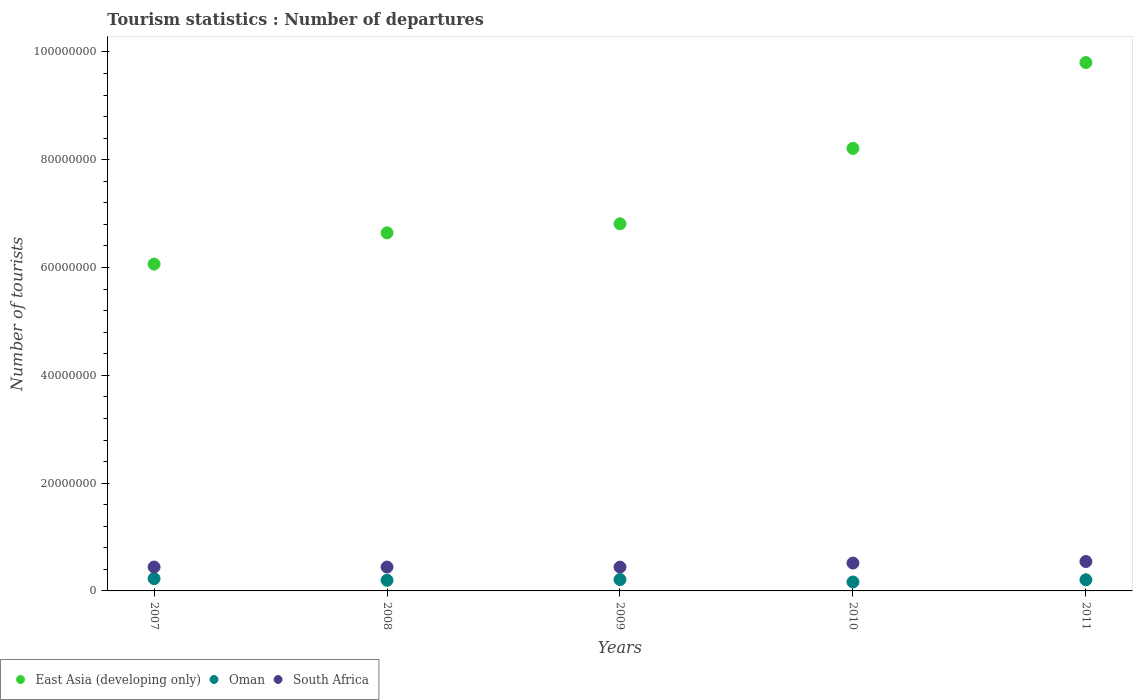What is the number of tourist departures in East Asia (developing only) in 2010?
Provide a short and direct response. 8.21e+07. Across all years, what is the maximum number of tourist departures in East Asia (developing only)?
Offer a very short reply. 9.80e+07. Across all years, what is the minimum number of tourist departures in South Africa?
Your answer should be very brief. 4.42e+06. What is the total number of tourist departures in Oman in the graph?
Offer a very short reply. 1.01e+07. What is the difference between the number of tourist departures in South Africa in 2007 and that in 2008?
Keep it short and to the point. 4000. What is the difference between the number of tourist departures in Oman in 2009 and the number of tourist departures in East Asia (developing only) in 2008?
Ensure brevity in your answer.  -6.43e+07. What is the average number of tourist departures in Oman per year?
Your answer should be very brief. 2.02e+06. In the year 2009, what is the difference between the number of tourist departures in Oman and number of tourist departures in East Asia (developing only)?
Provide a succinct answer. -6.60e+07. In how many years, is the number of tourist departures in South Africa greater than 56000000?
Your response must be concise. 0. What is the ratio of the number of tourist departures in South Africa in 2010 to that in 2011?
Your response must be concise. 0.95. Is the number of tourist departures in East Asia (developing only) in 2007 less than that in 2010?
Make the answer very short. Yes. Is the difference between the number of tourist departures in Oman in 2007 and 2008 greater than the difference between the number of tourist departures in East Asia (developing only) in 2007 and 2008?
Give a very brief answer. Yes. What is the difference between the highest and the lowest number of tourist departures in South Africa?
Offer a terse response. 1.03e+06. In how many years, is the number of tourist departures in South Africa greater than the average number of tourist departures in South Africa taken over all years?
Ensure brevity in your answer.  2. Does the number of tourist departures in Oman monotonically increase over the years?
Your answer should be compact. No. Is the number of tourist departures in East Asia (developing only) strictly greater than the number of tourist departures in South Africa over the years?
Give a very brief answer. Yes. Is the number of tourist departures in Oman strictly less than the number of tourist departures in South Africa over the years?
Give a very brief answer. Yes. How many dotlines are there?
Offer a terse response. 3. Does the graph contain any zero values?
Offer a very short reply. No. Does the graph contain grids?
Your response must be concise. No. What is the title of the graph?
Ensure brevity in your answer.  Tourism statistics : Number of departures. Does "Andorra" appear as one of the legend labels in the graph?
Ensure brevity in your answer.  No. What is the label or title of the X-axis?
Your response must be concise. Years. What is the label or title of the Y-axis?
Provide a succinct answer. Number of tourists. What is the Number of tourists of East Asia (developing only) in 2007?
Your answer should be compact. 6.06e+07. What is the Number of tourists in Oman in 2007?
Provide a succinct answer. 2.28e+06. What is the Number of tourists in South Africa in 2007?
Offer a terse response. 4.43e+06. What is the Number of tourists in East Asia (developing only) in 2008?
Provide a short and direct response. 6.64e+07. What is the Number of tourists in Oman in 2008?
Your answer should be compact. 1.97e+06. What is the Number of tourists of South Africa in 2008?
Your answer should be compact. 4.43e+06. What is the Number of tourists in East Asia (developing only) in 2009?
Ensure brevity in your answer.  6.81e+07. What is the Number of tourists in Oman in 2009?
Keep it short and to the point. 2.11e+06. What is the Number of tourists of South Africa in 2009?
Offer a terse response. 4.42e+06. What is the Number of tourists of East Asia (developing only) in 2010?
Provide a succinct answer. 8.21e+07. What is the Number of tourists in Oman in 2010?
Provide a short and direct response. 1.66e+06. What is the Number of tourists in South Africa in 2010?
Your response must be concise. 5.16e+06. What is the Number of tourists of East Asia (developing only) in 2011?
Make the answer very short. 9.80e+07. What is the Number of tourists of Oman in 2011?
Your answer should be very brief. 2.06e+06. What is the Number of tourists in South Africa in 2011?
Ensure brevity in your answer.  5.46e+06. Across all years, what is the maximum Number of tourists in East Asia (developing only)?
Your answer should be compact. 9.80e+07. Across all years, what is the maximum Number of tourists of Oman?
Provide a succinct answer. 2.28e+06. Across all years, what is the maximum Number of tourists in South Africa?
Offer a very short reply. 5.46e+06. Across all years, what is the minimum Number of tourists in East Asia (developing only)?
Keep it short and to the point. 6.06e+07. Across all years, what is the minimum Number of tourists in Oman?
Your answer should be very brief. 1.66e+06. Across all years, what is the minimum Number of tourists of South Africa?
Provide a short and direct response. 4.42e+06. What is the total Number of tourists of East Asia (developing only) in the graph?
Give a very brief answer. 3.75e+08. What is the total Number of tourists of Oman in the graph?
Offer a very short reply. 1.01e+07. What is the total Number of tourists of South Africa in the graph?
Keep it short and to the point. 2.39e+07. What is the difference between the Number of tourists in East Asia (developing only) in 2007 and that in 2008?
Ensure brevity in your answer.  -5.80e+06. What is the difference between the Number of tourists in Oman in 2007 and that in 2008?
Provide a short and direct response. 3.12e+05. What is the difference between the Number of tourists of South Africa in 2007 and that in 2008?
Make the answer very short. 4000. What is the difference between the Number of tourists in East Asia (developing only) in 2007 and that in 2009?
Make the answer very short. -7.47e+06. What is the difference between the Number of tourists of Oman in 2007 and that in 2009?
Your response must be concise. 1.77e+05. What is the difference between the Number of tourists in South Africa in 2007 and that in 2009?
Your answer should be compact. 9000. What is the difference between the Number of tourists in East Asia (developing only) in 2007 and that in 2010?
Your answer should be very brief. -2.15e+07. What is the difference between the Number of tourists of Oman in 2007 and that in 2010?
Provide a succinct answer. 6.30e+05. What is the difference between the Number of tourists of South Africa in 2007 and that in 2010?
Offer a very short reply. -7.32e+05. What is the difference between the Number of tourists of East Asia (developing only) in 2007 and that in 2011?
Your response must be concise. -3.74e+07. What is the difference between the Number of tourists in South Africa in 2007 and that in 2011?
Your answer should be very brief. -1.02e+06. What is the difference between the Number of tourists in East Asia (developing only) in 2008 and that in 2009?
Your answer should be very brief. -1.68e+06. What is the difference between the Number of tourists in Oman in 2008 and that in 2009?
Your answer should be compact. -1.35e+05. What is the difference between the Number of tourists of East Asia (developing only) in 2008 and that in 2010?
Ensure brevity in your answer.  -1.57e+07. What is the difference between the Number of tourists in Oman in 2008 and that in 2010?
Provide a short and direct response. 3.18e+05. What is the difference between the Number of tourists of South Africa in 2008 and that in 2010?
Offer a very short reply. -7.36e+05. What is the difference between the Number of tourists in East Asia (developing only) in 2008 and that in 2011?
Make the answer very short. -3.16e+07. What is the difference between the Number of tourists of Oman in 2008 and that in 2011?
Give a very brief answer. -9.20e+04. What is the difference between the Number of tourists in South Africa in 2008 and that in 2011?
Your answer should be very brief. -1.03e+06. What is the difference between the Number of tourists of East Asia (developing only) in 2009 and that in 2010?
Your answer should be very brief. -1.40e+07. What is the difference between the Number of tourists in Oman in 2009 and that in 2010?
Keep it short and to the point. 4.53e+05. What is the difference between the Number of tourists in South Africa in 2009 and that in 2010?
Keep it short and to the point. -7.41e+05. What is the difference between the Number of tourists in East Asia (developing only) in 2009 and that in 2011?
Your response must be concise. -2.99e+07. What is the difference between the Number of tourists in Oman in 2009 and that in 2011?
Give a very brief answer. 4.30e+04. What is the difference between the Number of tourists in South Africa in 2009 and that in 2011?
Offer a very short reply. -1.03e+06. What is the difference between the Number of tourists of East Asia (developing only) in 2010 and that in 2011?
Your response must be concise. -1.59e+07. What is the difference between the Number of tourists in Oman in 2010 and that in 2011?
Provide a short and direct response. -4.10e+05. What is the difference between the Number of tourists in South Africa in 2010 and that in 2011?
Make the answer very short. -2.90e+05. What is the difference between the Number of tourists of East Asia (developing only) in 2007 and the Number of tourists of Oman in 2008?
Keep it short and to the point. 5.87e+07. What is the difference between the Number of tourists in East Asia (developing only) in 2007 and the Number of tourists in South Africa in 2008?
Provide a succinct answer. 5.62e+07. What is the difference between the Number of tourists of Oman in 2007 and the Number of tourists of South Africa in 2008?
Your answer should be compact. -2.14e+06. What is the difference between the Number of tourists in East Asia (developing only) in 2007 and the Number of tourists in Oman in 2009?
Keep it short and to the point. 5.85e+07. What is the difference between the Number of tourists in East Asia (developing only) in 2007 and the Number of tourists in South Africa in 2009?
Provide a succinct answer. 5.62e+07. What is the difference between the Number of tourists in Oman in 2007 and the Number of tourists in South Africa in 2009?
Offer a terse response. -2.14e+06. What is the difference between the Number of tourists in East Asia (developing only) in 2007 and the Number of tourists in Oman in 2010?
Offer a very short reply. 5.90e+07. What is the difference between the Number of tourists in East Asia (developing only) in 2007 and the Number of tourists in South Africa in 2010?
Provide a short and direct response. 5.55e+07. What is the difference between the Number of tourists of Oman in 2007 and the Number of tourists of South Africa in 2010?
Your answer should be very brief. -2.88e+06. What is the difference between the Number of tourists in East Asia (developing only) in 2007 and the Number of tourists in Oman in 2011?
Your answer should be very brief. 5.86e+07. What is the difference between the Number of tourists of East Asia (developing only) in 2007 and the Number of tourists of South Africa in 2011?
Your response must be concise. 5.52e+07. What is the difference between the Number of tourists in Oman in 2007 and the Number of tourists in South Africa in 2011?
Your response must be concise. -3.17e+06. What is the difference between the Number of tourists of East Asia (developing only) in 2008 and the Number of tourists of Oman in 2009?
Provide a short and direct response. 6.43e+07. What is the difference between the Number of tourists of East Asia (developing only) in 2008 and the Number of tourists of South Africa in 2009?
Ensure brevity in your answer.  6.20e+07. What is the difference between the Number of tourists in Oman in 2008 and the Number of tourists in South Africa in 2009?
Make the answer very short. -2.45e+06. What is the difference between the Number of tourists of East Asia (developing only) in 2008 and the Number of tourists of Oman in 2010?
Keep it short and to the point. 6.48e+07. What is the difference between the Number of tourists in East Asia (developing only) in 2008 and the Number of tourists in South Africa in 2010?
Provide a short and direct response. 6.13e+07. What is the difference between the Number of tourists in Oman in 2008 and the Number of tourists in South Africa in 2010?
Your answer should be compact. -3.19e+06. What is the difference between the Number of tourists of East Asia (developing only) in 2008 and the Number of tourists of Oman in 2011?
Make the answer very short. 6.44e+07. What is the difference between the Number of tourists in East Asia (developing only) in 2008 and the Number of tourists in South Africa in 2011?
Your response must be concise. 6.10e+07. What is the difference between the Number of tourists of Oman in 2008 and the Number of tourists of South Africa in 2011?
Offer a very short reply. -3.48e+06. What is the difference between the Number of tourists of East Asia (developing only) in 2009 and the Number of tourists of Oman in 2010?
Make the answer very short. 6.65e+07. What is the difference between the Number of tourists of East Asia (developing only) in 2009 and the Number of tourists of South Africa in 2010?
Make the answer very short. 6.30e+07. What is the difference between the Number of tourists in Oman in 2009 and the Number of tourists in South Africa in 2010?
Give a very brief answer. -3.06e+06. What is the difference between the Number of tourists of East Asia (developing only) in 2009 and the Number of tourists of Oman in 2011?
Offer a very short reply. 6.61e+07. What is the difference between the Number of tourists in East Asia (developing only) in 2009 and the Number of tourists in South Africa in 2011?
Give a very brief answer. 6.27e+07. What is the difference between the Number of tourists in Oman in 2009 and the Number of tourists in South Africa in 2011?
Give a very brief answer. -3.35e+06. What is the difference between the Number of tourists of East Asia (developing only) in 2010 and the Number of tourists of Oman in 2011?
Make the answer very short. 8.00e+07. What is the difference between the Number of tourists in East Asia (developing only) in 2010 and the Number of tourists in South Africa in 2011?
Offer a very short reply. 7.67e+07. What is the difference between the Number of tourists in Oman in 2010 and the Number of tourists in South Africa in 2011?
Keep it short and to the point. -3.80e+06. What is the average Number of tourists in East Asia (developing only) per year?
Provide a short and direct response. 7.51e+07. What is the average Number of tourists in Oman per year?
Ensure brevity in your answer.  2.02e+06. What is the average Number of tourists in South Africa per year?
Your answer should be compact. 4.78e+06. In the year 2007, what is the difference between the Number of tourists in East Asia (developing only) and Number of tourists in Oman?
Keep it short and to the point. 5.84e+07. In the year 2007, what is the difference between the Number of tourists of East Asia (developing only) and Number of tourists of South Africa?
Offer a terse response. 5.62e+07. In the year 2007, what is the difference between the Number of tourists of Oman and Number of tourists of South Africa?
Keep it short and to the point. -2.15e+06. In the year 2008, what is the difference between the Number of tourists in East Asia (developing only) and Number of tourists in Oman?
Provide a succinct answer. 6.45e+07. In the year 2008, what is the difference between the Number of tourists of East Asia (developing only) and Number of tourists of South Africa?
Your answer should be very brief. 6.20e+07. In the year 2008, what is the difference between the Number of tourists of Oman and Number of tourists of South Africa?
Your answer should be very brief. -2.46e+06. In the year 2009, what is the difference between the Number of tourists in East Asia (developing only) and Number of tourists in Oman?
Make the answer very short. 6.60e+07. In the year 2009, what is the difference between the Number of tourists in East Asia (developing only) and Number of tourists in South Africa?
Your answer should be compact. 6.37e+07. In the year 2009, what is the difference between the Number of tourists in Oman and Number of tourists in South Africa?
Make the answer very short. -2.32e+06. In the year 2010, what is the difference between the Number of tourists in East Asia (developing only) and Number of tourists in Oman?
Provide a succinct answer. 8.05e+07. In the year 2010, what is the difference between the Number of tourists of East Asia (developing only) and Number of tourists of South Africa?
Provide a short and direct response. 7.69e+07. In the year 2010, what is the difference between the Number of tourists of Oman and Number of tourists of South Africa?
Keep it short and to the point. -3.51e+06. In the year 2011, what is the difference between the Number of tourists of East Asia (developing only) and Number of tourists of Oman?
Give a very brief answer. 9.60e+07. In the year 2011, what is the difference between the Number of tourists in East Asia (developing only) and Number of tourists in South Africa?
Make the answer very short. 9.26e+07. In the year 2011, what is the difference between the Number of tourists of Oman and Number of tourists of South Africa?
Offer a terse response. -3.39e+06. What is the ratio of the Number of tourists of East Asia (developing only) in 2007 to that in 2008?
Keep it short and to the point. 0.91. What is the ratio of the Number of tourists of Oman in 2007 to that in 2008?
Give a very brief answer. 1.16. What is the ratio of the Number of tourists of East Asia (developing only) in 2007 to that in 2009?
Keep it short and to the point. 0.89. What is the ratio of the Number of tourists of Oman in 2007 to that in 2009?
Offer a very short reply. 1.08. What is the ratio of the Number of tourists of South Africa in 2007 to that in 2009?
Keep it short and to the point. 1. What is the ratio of the Number of tourists in East Asia (developing only) in 2007 to that in 2010?
Give a very brief answer. 0.74. What is the ratio of the Number of tourists in Oman in 2007 to that in 2010?
Provide a short and direct response. 1.38. What is the ratio of the Number of tourists of South Africa in 2007 to that in 2010?
Your response must be concise. 0.86. What is the ratio of the Number of tourists in East Asia (developing only) in 2007 to that in 2011?
Offer a terse response. 0.62. What is the ratio of the Number of tourists of Oman in 2007 to that in 2011?
Give a very brief answer. 1.11. What is the ratio of the Number of tourists in South Africa in 2007 to that in 2011?
Offer a terse response. 0.81. What is the ratio of the Number of tourists in East Asia (developing only) in 2008 to that in 2009?
Keep it short and to the point. 0.98. What is the ratio of the Number of tourists in Oman in 2008 to that in 2009?
Your answer should be compact. 0.94. What is the ratio of the Number of tourists in South Africa in 2008 to that in 2009?
Offer a very short reply. 1. What is the ratio of the Number of tourists in East Asia (developing only) in 2008 to that in 2010?
Provide a short and direct response. 0.81. What is the ratio of the Number of tourists in Oman in 2008 to that in 2010?
Ensure brevity in your answer.  1.19. What is the ratio of the Number of tourists of South Africa in 2008 to that in 2010?
Offer a terse response. 0.86. What is the ratio of the Number of tourists in East Asia (developing only) in 2008 to that in 2011?
Your response must be concise. 0.68. What is the ratio of the Number of tourists in Oman in 2008 to that in 2011?
Your answer should be compact. 0.96. What is the ratio of the Number of tourists in South Africa in 2008 to that in 2011?
Keep it short and to the point. 0.81. What is the ratio of the Number of tourists in East Asia (developing only) in 2009 to that in 2010?
Provide a short and direct response. 0.83. What is the ratio of the Number of tourists in Oman in 2009 to that in 2010?
Offer a very short reply. 1.27. What is the ratio of the Number of tourists of South Africa in 2009 to that in 2010?
Your answer should be very brief. 0.86. What is the ratio of the Number of tourists of East Asia (developing only) in 2009 to that in 2011?
Your response must be concise. 0.69. What is the ratio of the Number of tourists in Oman in 2009 to that in 2011?
Provide a short and direct response. 1.02. What is the ratio of the Number of tourists of South Africa in 2009 to that in 2011?
Offer a very short reply. 0.81. What is the ratio of the Number of tourists of East Asia (developing only) in 2010 to that in 2011?
Make the answer very short. 0.84. What is the ratio of the Number of tourists of Oman in 2010 to that in 2011?
Provide a short and direct response. 0.8. What is the ratio of the Number of tourists of South Africa in 2010 to that in 2011?
Provide a succinct answer. 0.95. What is the difference between the highest and the second highest Number of tourists in East Asia (developing only)?
Keep it short and to the point. 1.59e+07. What is the difference between the highest and the second highest Number of tourists in Oman?
Offer a very short reply. 1.77e+05. What is the difference between the highest and the second highest Number of tourists of South Africa?
Make the answer very short. 2.90e+05. What is the difference between the highest and the lowest Number of tourists in East Asia (developing only)?
Your answer should be compact. 3.74e+07. What is the difference between the highest and the lowest Number of tourists in Oman?
Your response must be concise. 6.30e+05. What is the difference between the highest and the lowest Number of tourists of South Africa?
Your answer should be very brief. 1.03e+06. 